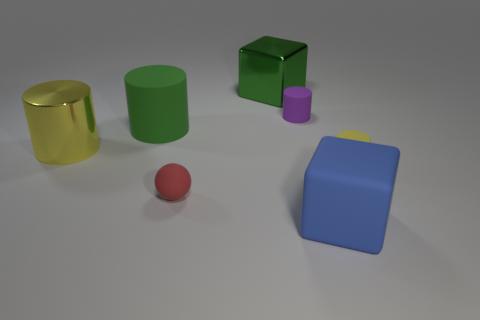There is a tiny matte thing that is the same color as the big metal cylinder; what is its shape?
Your answer should be compact. Cylinder. Does the cube that is in front of the large green metal block have the same material as the small object that is behind the tiny yellow rubber object?
Your answer should be very brief. Yes. Is there any other thing that has the same shape as the blue matte object?
Give a very brief answer. Yes. The rubber block is what color?
Your answer should be very brief. Blue. How many other small rubber things have the same shape as the purple matte thing?
Ensure brevity in your answer.  1. There is another metallic cylinder that is the same size as the green cylinder; what is its color?
Your answer should be very brief. Yellow. Is there a big yellow matte ball?
Ensure brevity in your answer.  No. What shape is the green object behind the small purple object?
Ensure brevity in your answer.  Cube. How many small rubber objects are both in front of the yellow metal cylinder and on the right side of the green shiny object?
Your response must be concise. 1. Is there a large brown cylinder made of the same material as the tiny ball?
Ensure brevity in your answer.  No. 